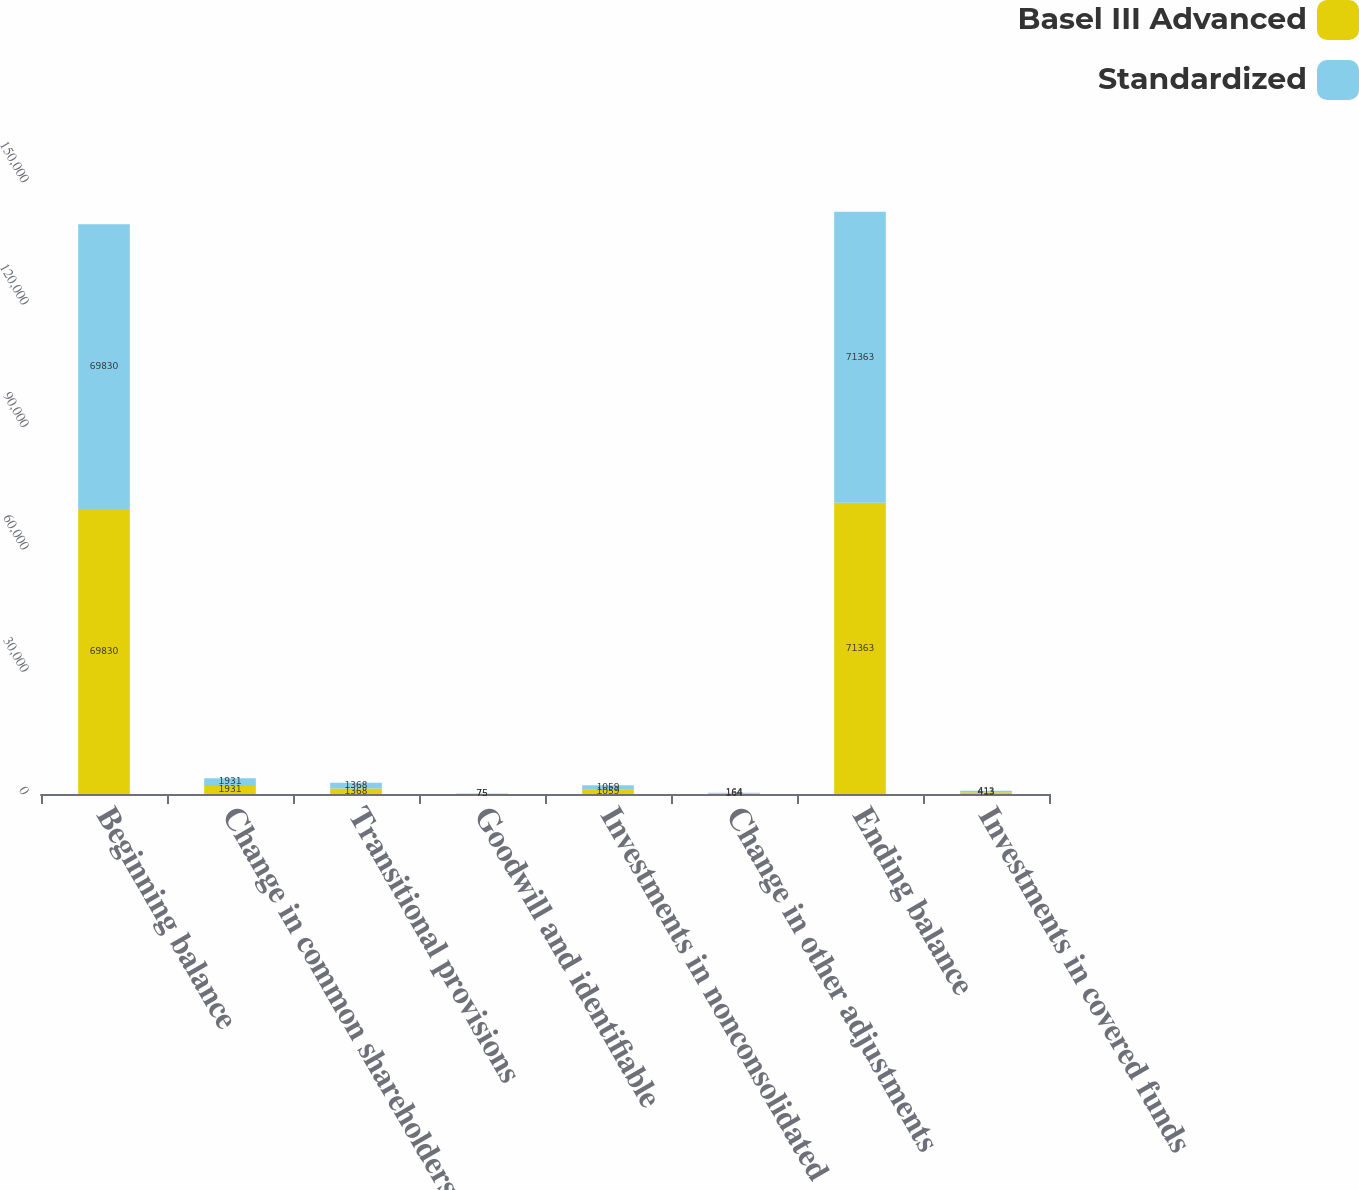Convert chart to OTSL. <chart><loc_0><loc_0><loc_500><loc_500><stacked_bar_chart><ecel><fcel>Beginning balance<fcel>Change in common shareholders'<fcel>Transitional provisions<fcel>Goodwill and identifiable<fcel>Investments in nonconsolidated<fcel>Change in other adjustments<fcel>Ending balance<fcel>Investments in covered funds<nl><fcel>Basel III Advanced<fcel>69830<fcel>1931<fcel>1368<fcel>75<fcel>1059<fcel>164<fcel>71363<fcel>413<nl><fcel>Standardized<fcel>69830<fcel>1931<fcel>1368<fcel>75<fcel>1059<fcel>164<fcel>71363<fcel>413<nl></chart> 